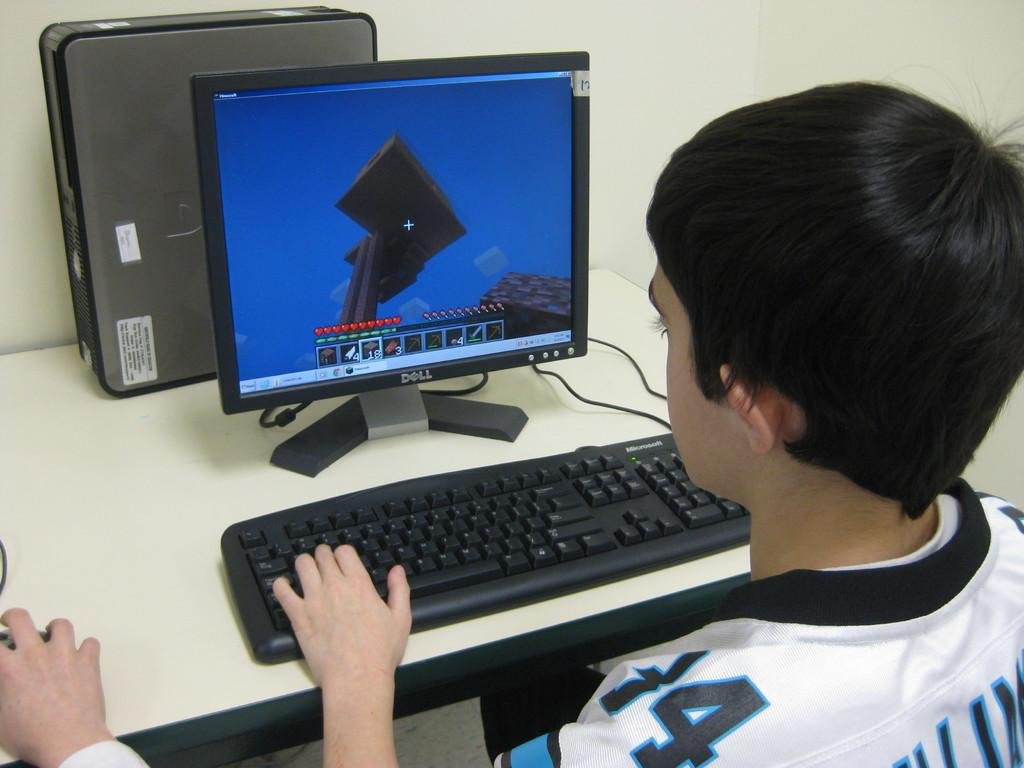Provide a one-sentence caption for the provided image. a boy using a DELL computer and keyboard. 